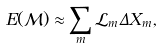Convert formula to latex. <formula><loc_0><loc_0><loc_500><loc_500>E ( \mathcal { M } ) \approx \sum _ { m } \mathcal { L } _ { m } \Delta X _ { m } ,</formula> 